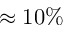<formula> <loc_0><loc_0><loc_500><loc_500>\approx 1 0 \%</formula> 